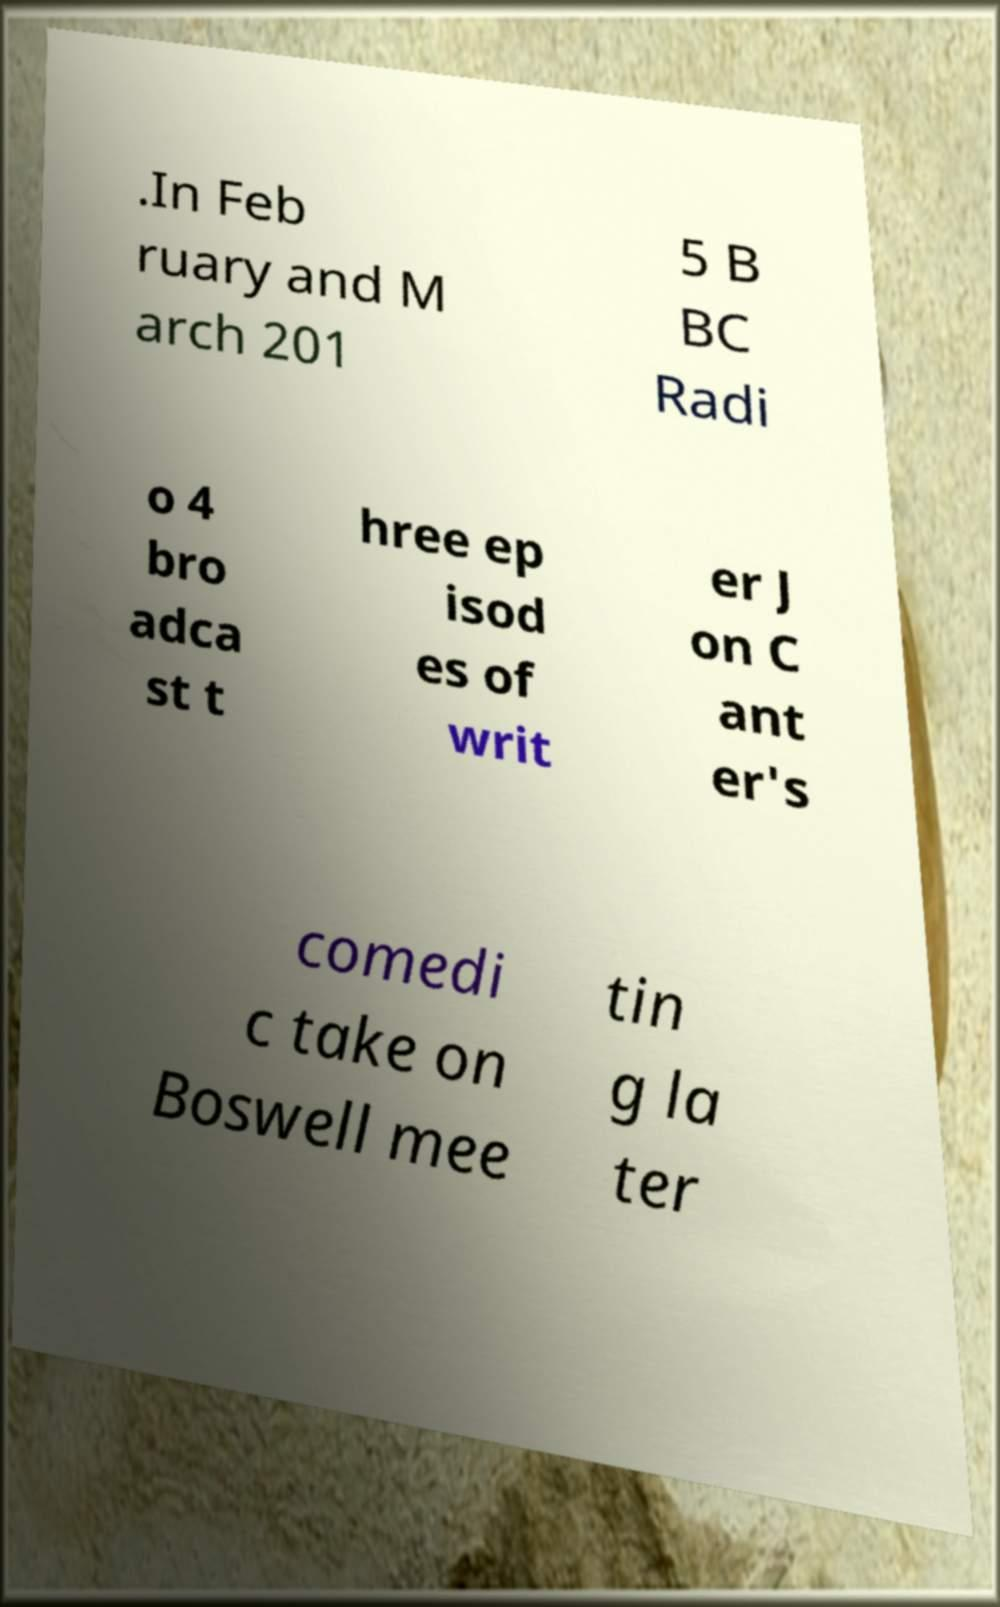Can you accurately transcribe the text from the provided image for me? .In Feb ruary and M arch 201 5 B BC Radi o 4 bro adca st t hree ep isod es of writ er J on C ant er's comedi c take on Boswell mee tin g la ter 